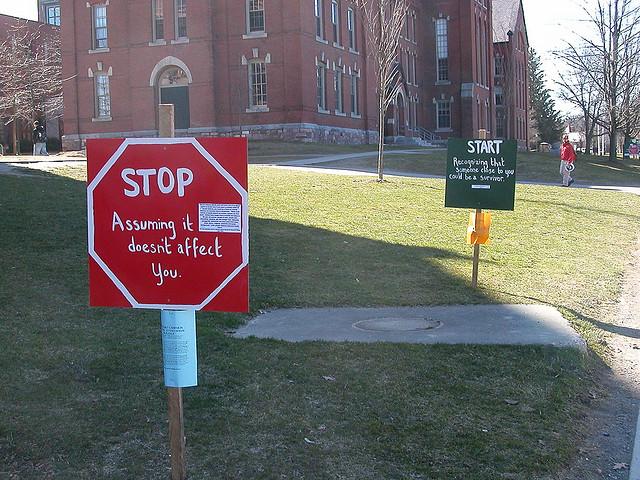What color is the paper under the stop sign?
Answer briefly. White. Do the signs look professional?
Short answer required. No. What material is the building made from?
Give a very brief answer. Brick. What is the first word on the green sign?
Short answer required. Start. 